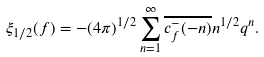Convert formula to latex. <formula><loc_0><loc_0><loc_500><loc_500>\xi _ { 1 / 2 } ( f ) = - ( 4 \pi ) ^ { 1 / 2 } \sum _ { n = 1 } ^ { \infty } \overline { c _ { f } ^ { - } ( - n ) } n ^ { 1 / 2 } q ^ { n } .</formula> 